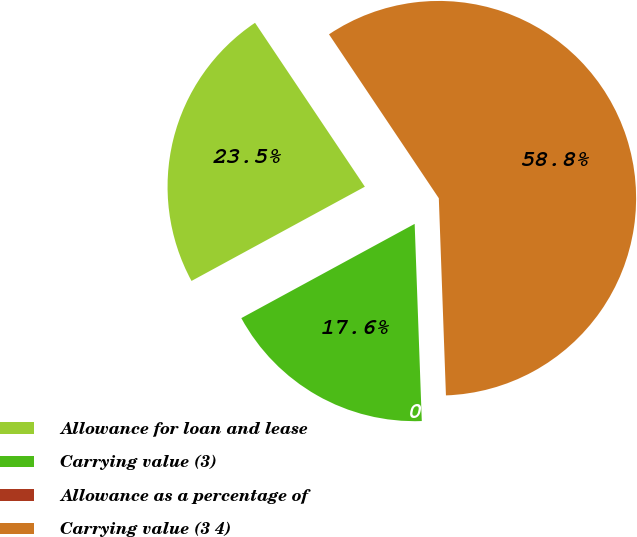Convert chart to OTSL. <chart><loc_0><loc_0><loc_500><loc_500><pie_chart><fcel>Allowance for loan and lease<fcel>Carrying value (3)<fcel>Allowance as a percentage of<fcel>Carrying value (3 4)<nl><fcel>23.53%<fcel>17.65%<fcel>0.0%<fcel>58.82%<nl></chart> 